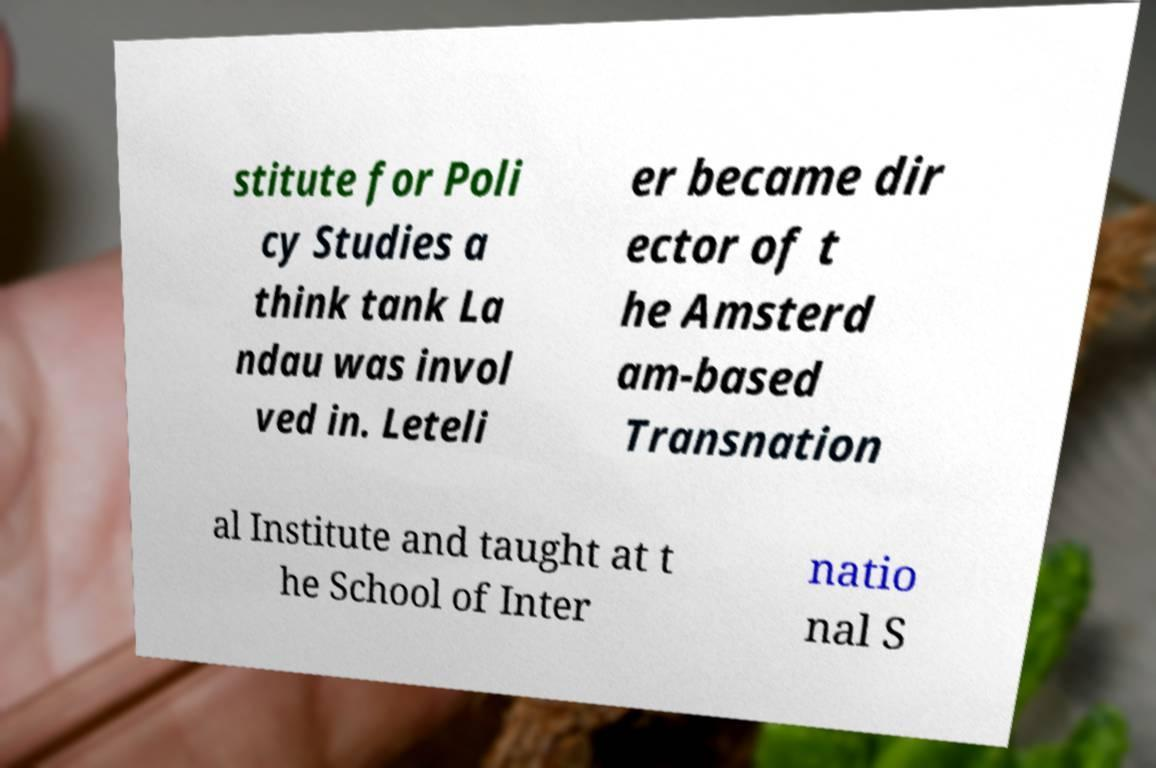Please identify and transcribe the text found in this image. stitute for Poli cy Studies a think tank La ndau was invol ved in. Leteli er became dir ector of t he Amsterd am-based Transnation al Institute and taught at t he School of Inter natio nal S 